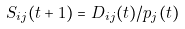<formula> <loc_0><loc_0><loc_500><loc_500>S _ { i j } ( t + 1 ) = D _ { i j } ( t ) / p _ { j } ( t )</formula> 